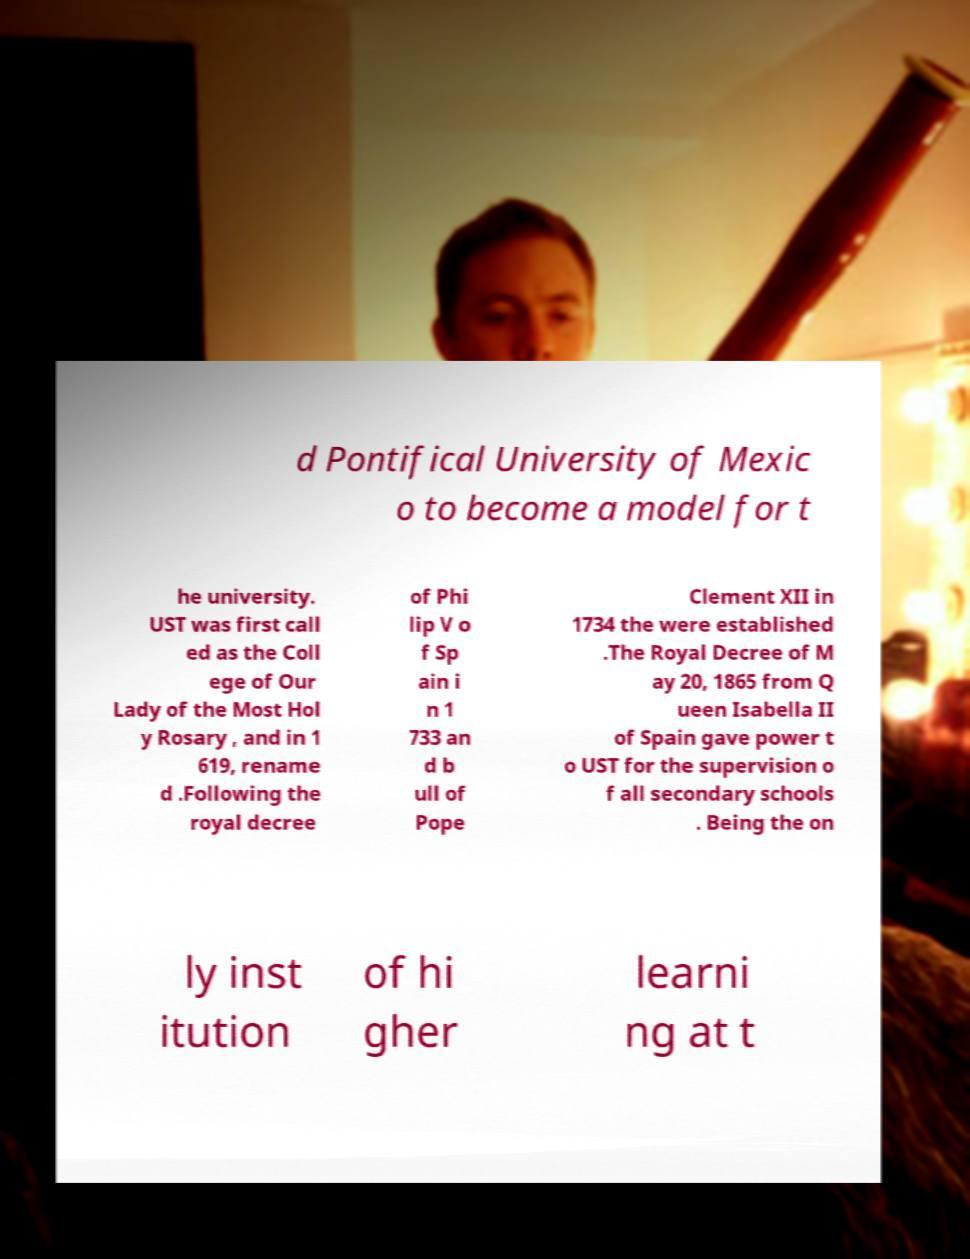For documentation purposes, I need the text within this image transcribed. Could you provide that? d Pontifical University of Mexic o to become a model for t he university. UST was first call ed as the Coll ege of Our Lady of the Most Hol y Rosary , and in 1 619, rename d .Following the royal decree of Phi lip V o f Sp ain i n 1 733 an d b ull of Pope Clement XII in 1734 the were established .The Royal Decree of M ay 20, 1865 from Q ueen Isabella II of Spain gave power t o UST for the supervision o f all secondary schools . Being the on ly inst itution of hi gher learni ng at t 